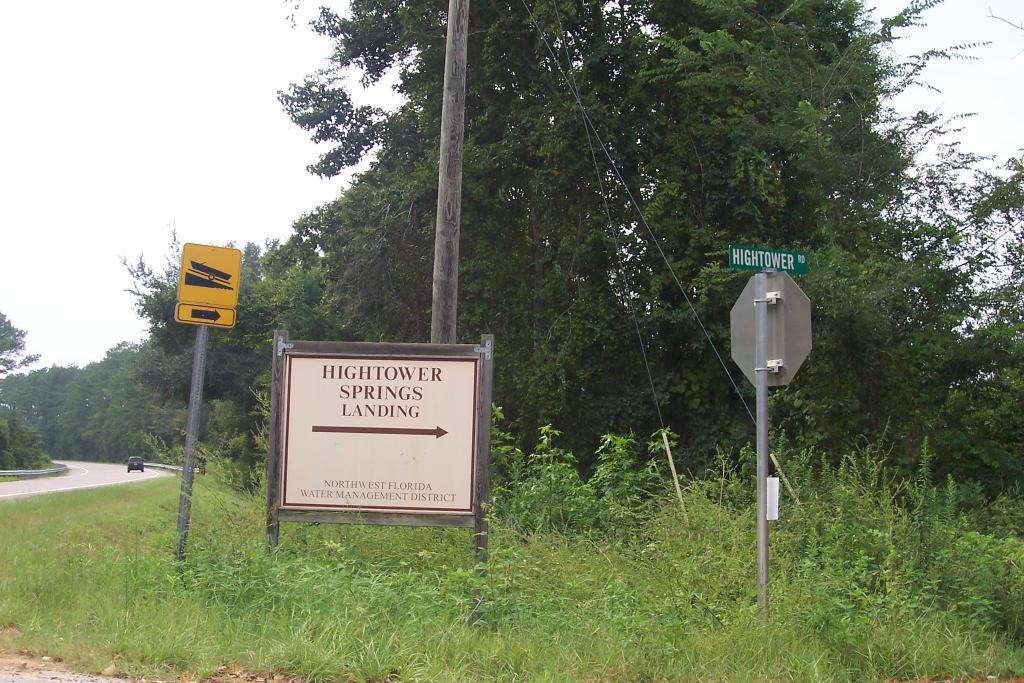What can be seen on the grass land in the image? There are sign boards on the grass land in the image. What is the background of the image? The background of the image includes trees. What is happening on the road in the image? There is a car moving on the road in the image. What part of the natural environment is visible in the image? The sky is visible in the image. What type of bead is being used to frame the trees in the image? There is no bead present in the image, nor is there any framing of the trees. How does the car in the image get the attention of the trees? The car in the image does not interact with the trees, so it cannot get their attention. 